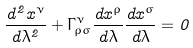<formula> <loc_0><loc_0><loc_500><loc_500>\frac { d ^ { 2 } x ^ { \nu } } { d \lambda ^ { 2 } } + \Gamma ^ { \nu } _ { \rho \sigma } \frac { d x ^ { \rho } } { d \lambda } \frac { d x ^ { \sigma } } { d \lambda } = 0</formula> 